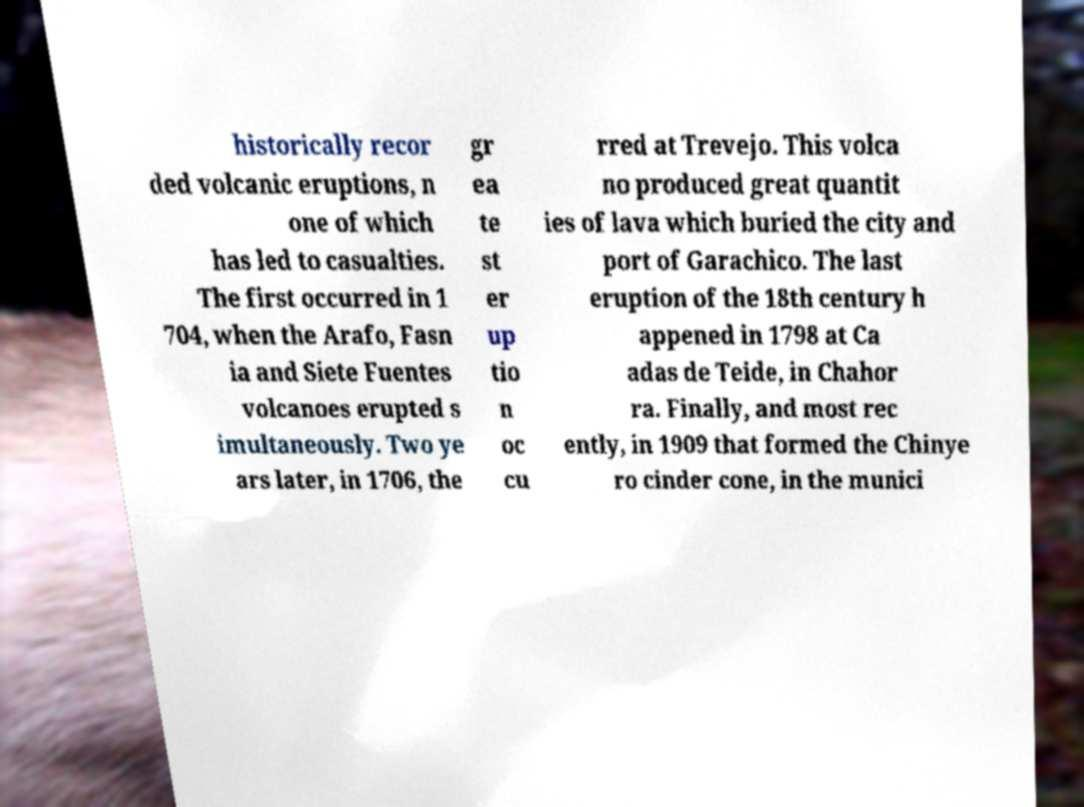For documentation purposes, I need the text within this image transcribed. Could you provide that? historically recor ded volcanic eruptions, n one of which has led to casualties. The first occurred in 1 704, when the Arafo, Fasn ia and Siete Fuentes volcanoes erupted s imultaneously. Two ye ars later, in 1706, the gr ea te st er up tio n oc cu rred at Trevejo. This volca no produced great quantit ies of lava which buried the city and port of Garachico. The last eruption of the 18th century h appened in 1798 at Ca adas de Teide, in Chahor ra. Finally, and most rec ently, in 1909 that formed the Chinye ro cinder cone, in the munici 